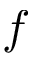Convert formula to latex. <formula><loc_0><loc_0><loc_500><loc_500>f</formula> 